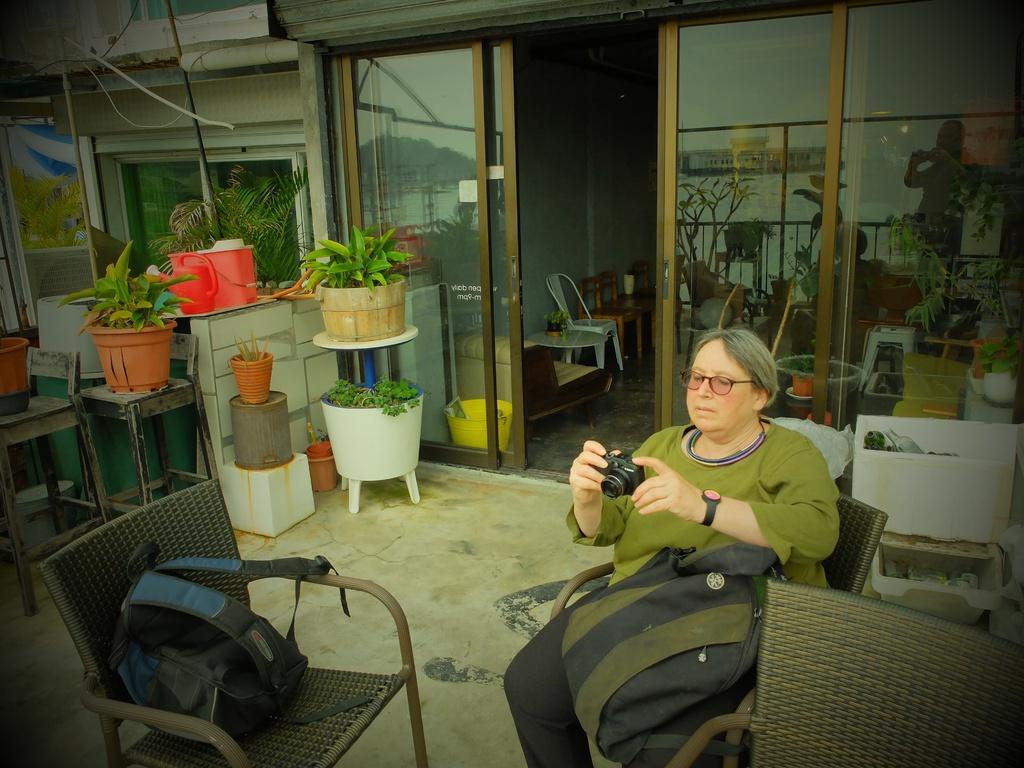Please provide a concise description of this image. In this picture we can see a lady sitting on the chair and holding the camera and also two backpacks and other two chairs and some plants on the tables and some chairs around her. 